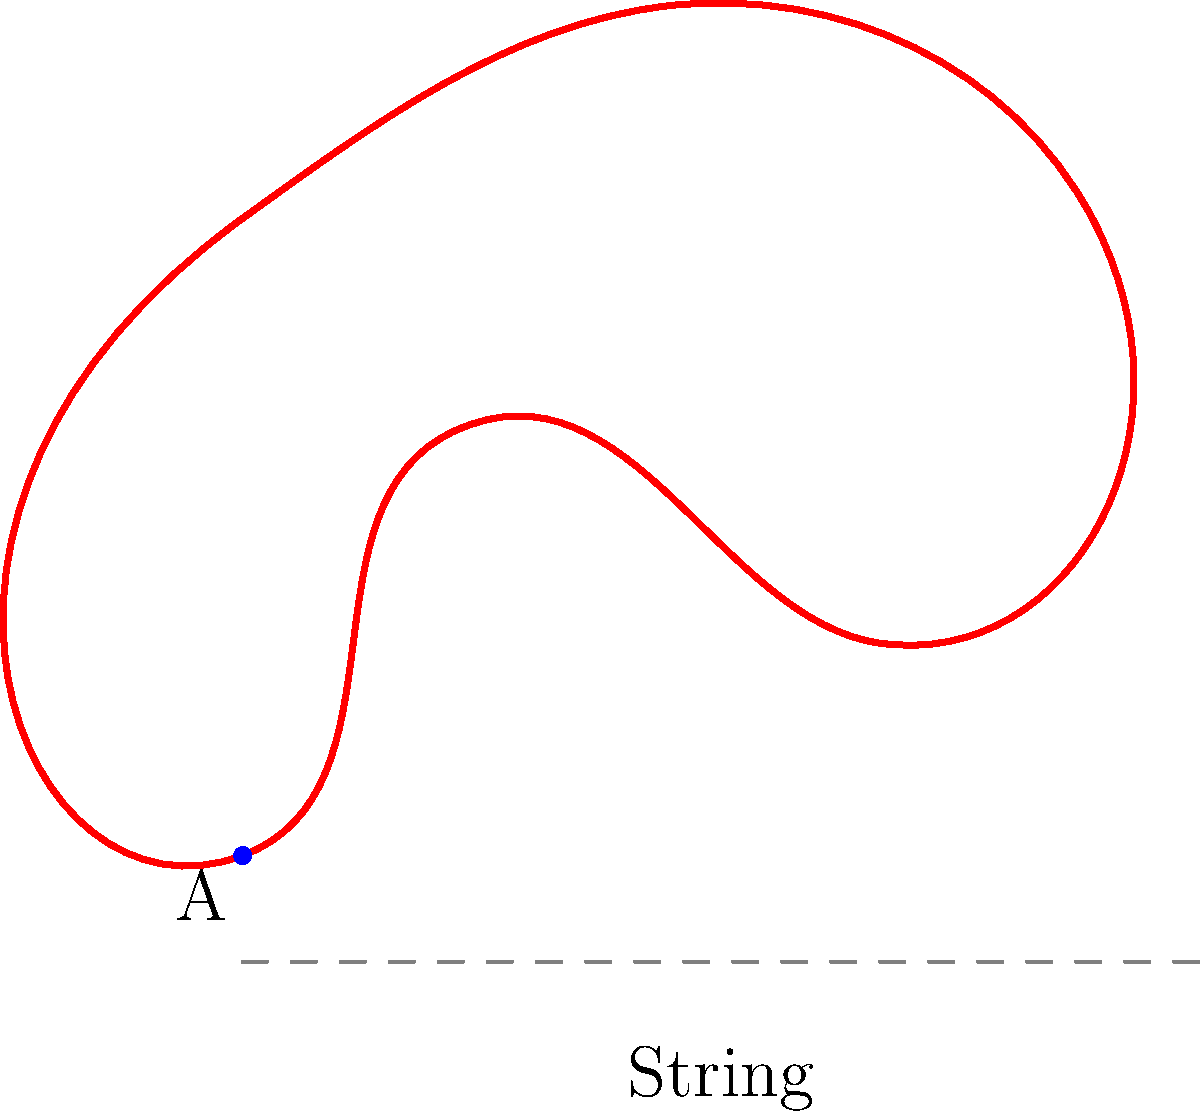You have an irregularly shaped cut of steak on your cutting board. To determine its perimeter, you decide to use a piece of string to trace around the edge of the steak. After tracing the entire perimeter, you measure the length of the used string to be 14 inches. What is the perimeter of the steak in centimeters, given that 1 inch is approximately equal to 2.54 cm? To solve this problem, we need to follow these steps:

1. Understand the given information:
   - The perimeter of the steak is measured using a string
   - The length of the string used is 14 inches
   - We need to convert the measurement to centimeters
   - 1 inch = 2.54 cm

2. Set up the conversion equation:
   Let $x$ be the perimeter in centimeters.
   $$x \text{ cm} = 14 \text{ inches} \times 2.54 \text{ cm/inch}$$

3. Perform the calculation:
   $$x = 14 \times 2.54 = 35.56 \text{ cm}$$

4. Round the result to a reasonable number of decimal places:
   In this case, rounding to two decimal places is appropriate for a measurement in centimeters.
   $$x \approx 35.56 \text{ cm}$$

Therefore, the perimeter of the irregularly shaped cut of steak is approximately 35.56 cm.
Answer: 35.56 cm 